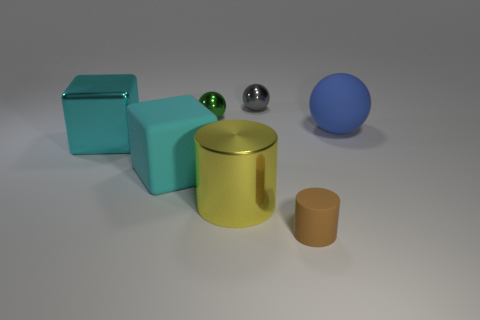The sphere that is the same size as the cyan metal block is what color?
Offer a very short reply. Blue. There is a matte thing that is the same shape as the large yellow metal object; what is its size?
Offer a very short reply. Small. There is a small object in front of the tiny green ball; what is its shape?
Provide a succinct answer. Cylinder. Do the brown thing and the rubber thing on the left side of the green ball have the same shape?
Provide a succinct answer. No. Are there the same number of large blue matte spheres that are to the right of the small matte object and yellow metallic cylinders that are in front of the rubber ball?
Give a very brief answer. Yes. What shape is the metal thing that is the same color as the big rubber cube?
Your answer should be very brief. Cube. There is a big rubber thing in front of the blue thing; is it the same color as the big shiny object on the left side of the large yellow cylinder?
Offer a terse response. Yes. Are there more shiny spheres on the left side of the tiny gray thing than blue cylinders?
Give a very brief answer. Yes. What is the big cylinder made of?
Offer a very short reply. Metal. What is the shape of the green thing that is made of the same material as the tiny gray object?
Provide a short and direct response. Sphere. 